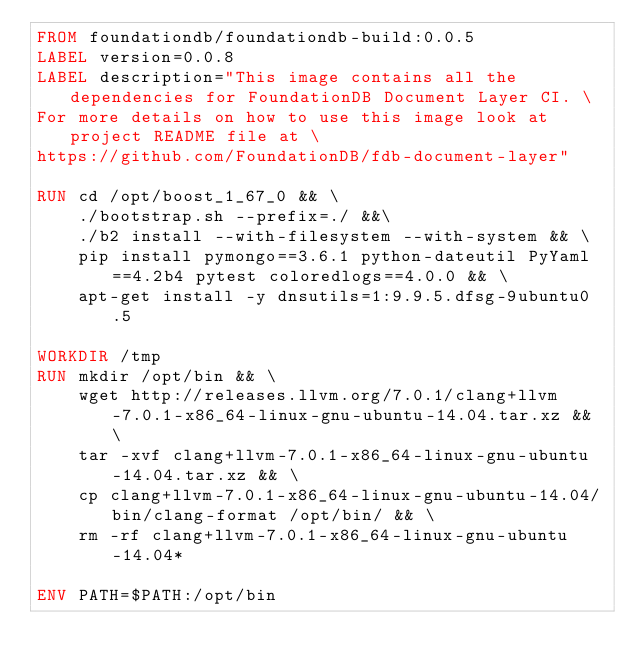Convert code to text. <code><loc_0><loc_0><loc_500><loc_500><_Dockerfile_>FROM foundationdb/foundationdb-build:0.0.5
LABEL version=0.0.8
LABEL description="This image contains all the dependencies for FoundationDB Document Layer CI. \
For more details on how to use this image look at project README file at \
https://github.com/FoundationDB/fdb-document-layer"

RUN cd /opt/boost_1_67_0 && \
	./bootstrap.sh --prefix=./ &&\
	./b2 install --with-filesystem --with-system && \
	pip install pymongo==3.6.1 python-dateutil PyYaml==4.2b4 pytest coloredlogs==4.0.0 && \
	apt-get install -y dnsutils=1:9.9.5.dfsg-9ubuntu0.5

WORKDIR /tmp
RUN mkdir /opt/bin && \
    wget http://releases.llvm.org/7.0.1/clang+llvm-7.0.1-x86_64-linux-gnu-ubuntu-14.04.tar.xz && \
    tar -xvf clang+llvm-7.0.1-x86_64-linux-gnu-ubuntu-14.04.tar.xz && \
    cp clang+llvm-7.0.1-x86_64-linux-gnu-ubuntu-14.04/bin/clang-format /opt/bin/ && \
    rm -rf clang+llvm-7.0.1-x86_64-linux-gnu-ubuntu-14.04*

ENV PATH=$PATH:/opt/bin
</code> 